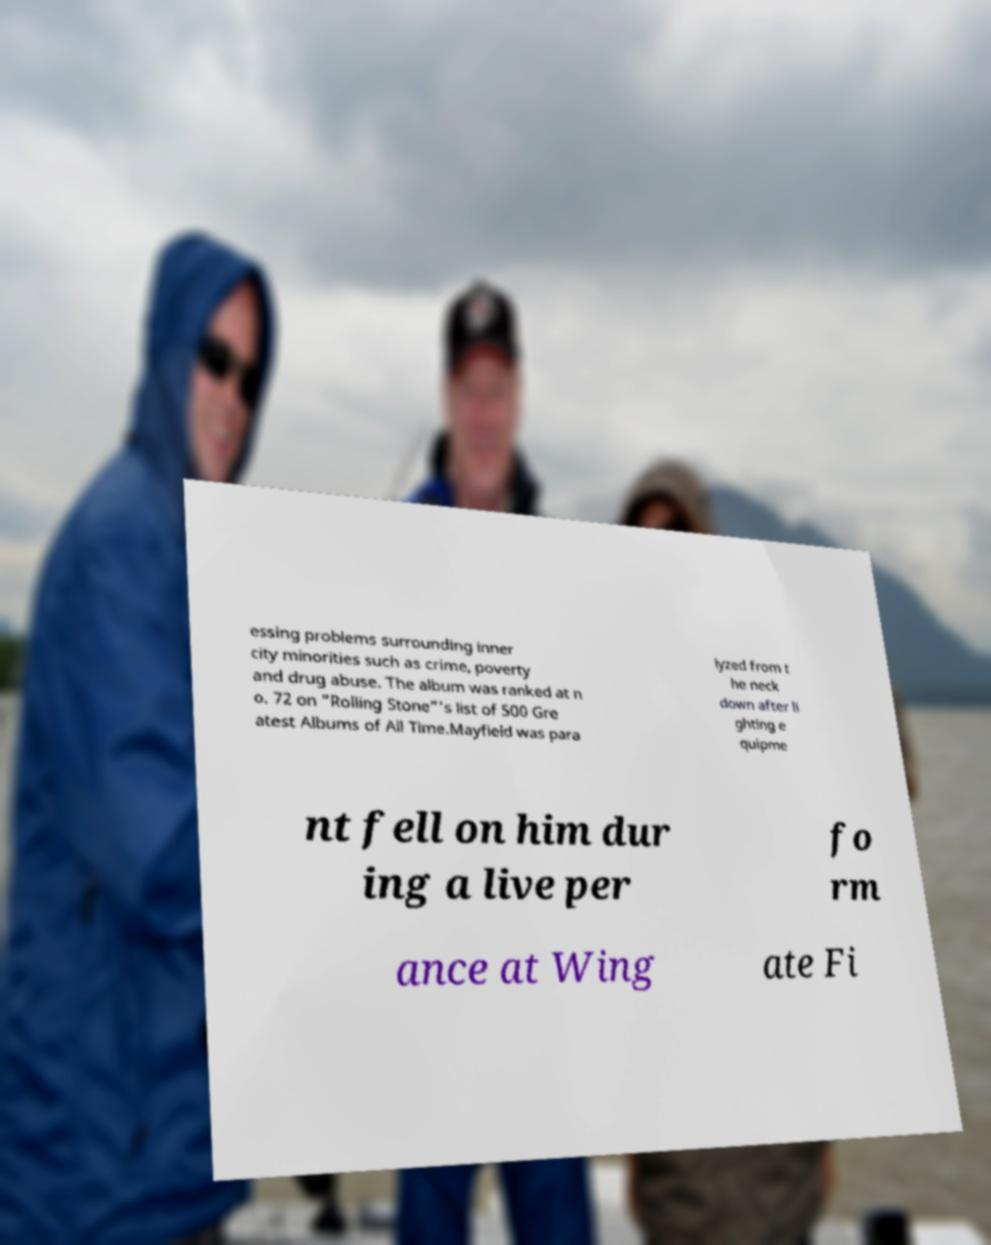For documentation purposes, I need the text within this image transcribed. Could you provide that? essing problems surrounding inner city minorities such as crime, poverty and drug abuse. The album was ranked at n o. 72 on "Rolling Stone"'s list of 500 Gre atest Albums of All Time.Mayfield was para lyzed from t he neck down after li ghting e quipme nt fell on him dur ing a live per fo rm ance at Wing ate Fi 